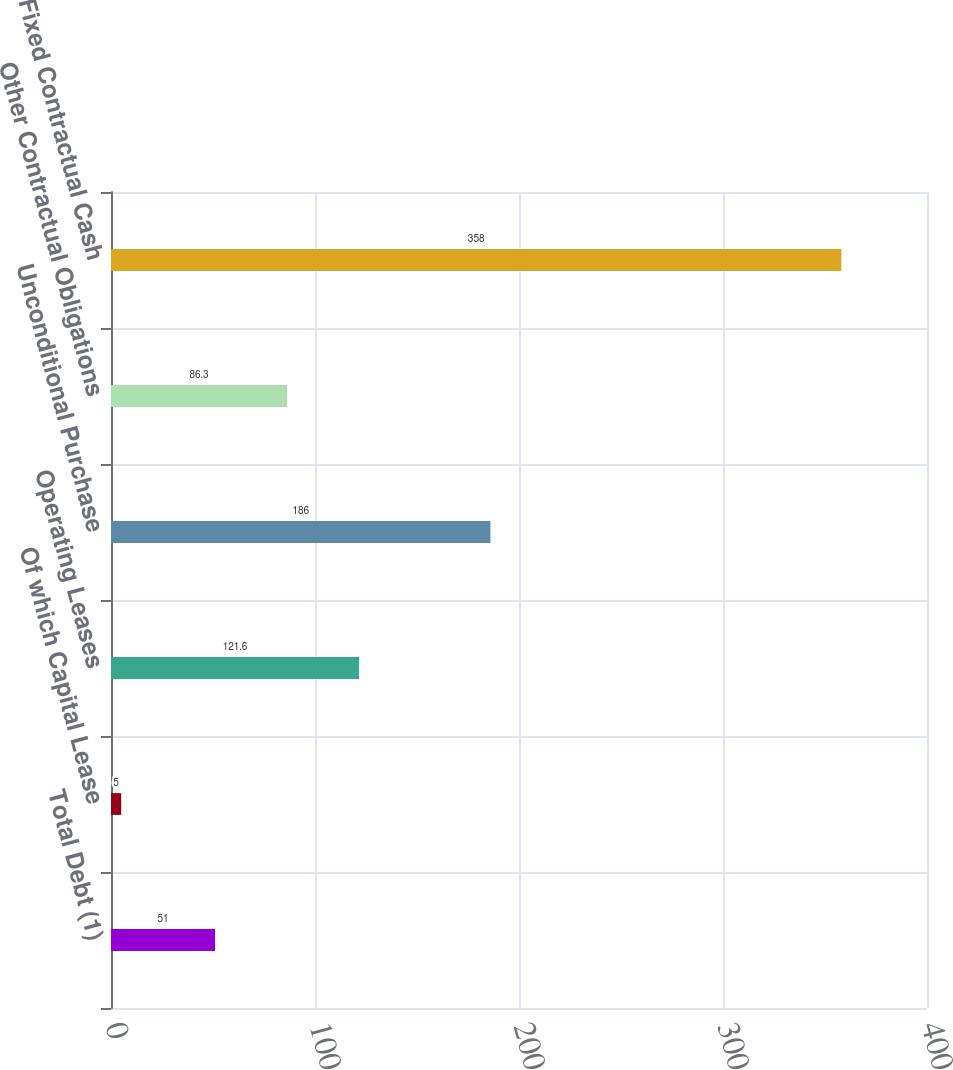Convert chart. <chart><loc_0><loc_0><loc_500><loc_500><bar_chart><fcel>Total Debt (1)<fcel>Of which Capital Lease<fcel>Operating Leases<fcel>Unconditional Purchase<fcel>Other Contractual Obligations<fcel>Fixed Contractual Cash<nl><fcel>51<fcel>5<fcel>121.6<fcel>186<fcel>86.3<fcel>358<nl></chart> 